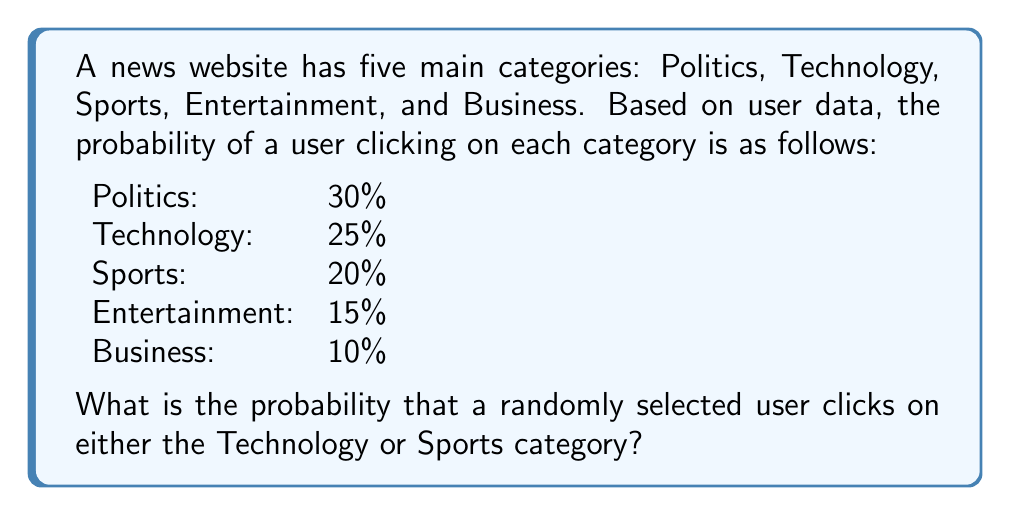Teach me how to tackle this problem. To solve this problem, we need to follow these steps:

1. Identify the probabilities of the events we're interested in:
   P(Technology) = 25% = 0.25
   P(Sports) = 20% = 0.20

2. Since we want the probability of a user clicking on either Technology OR Sports, we need to add these probabilities together. This is because the events are mutually exclusive (a user can't click on both categories simultaneously).

3. Calculate the sum of the probabilities:
   
   $$P(\text{Technology or Sports}) = P(\text{Technology}) + P(\text{Sports})$$
   $$P(\text{Technology or Sports}) = 0.25 + 0.20 = 0.45$$

4. Convert the result to a percentage:
   0.45 * 100 = 45%

Therefore, the probability that a randomly selected user clicks on either the Technology or Sports category is 45%.
Answer: 45% 